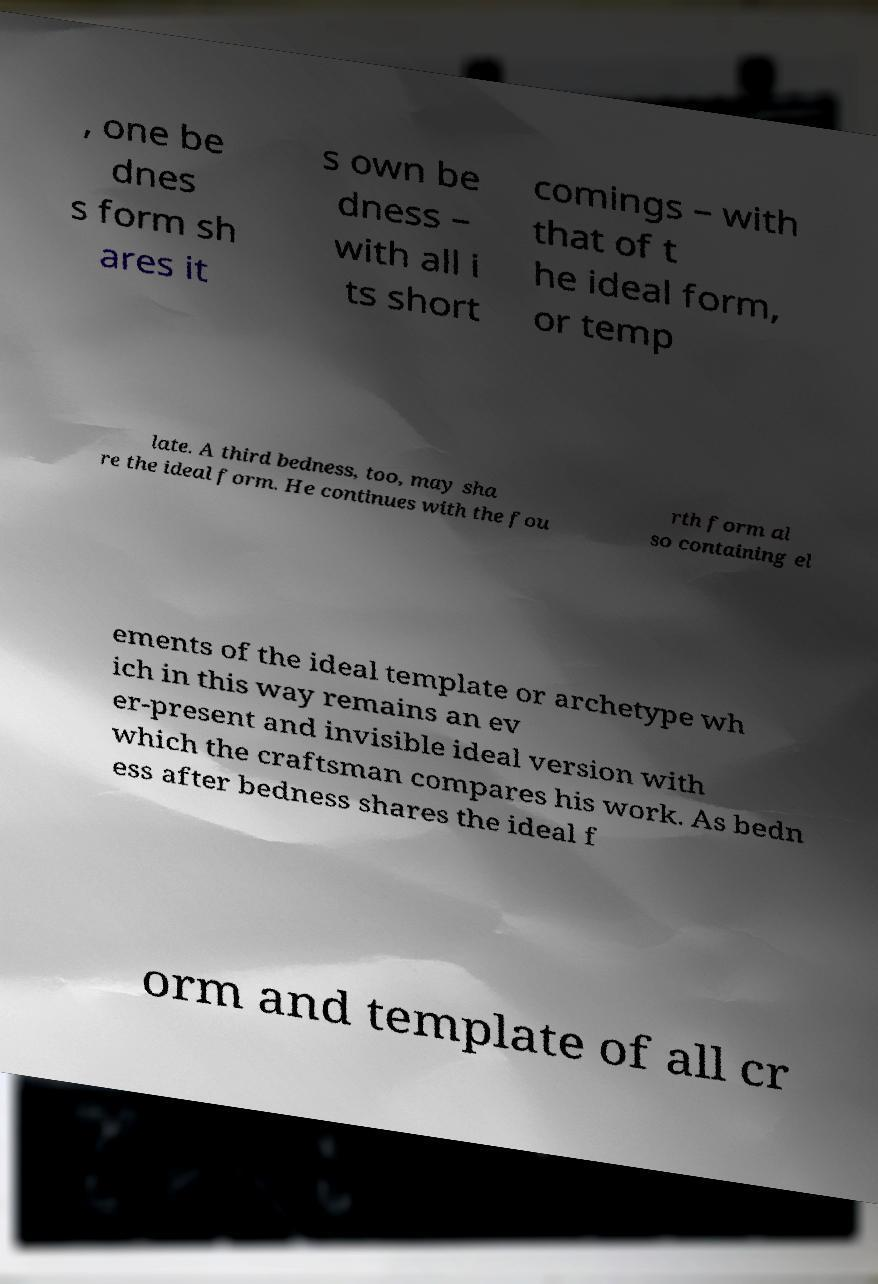Could you assist in decoding the text presented in this image and type it out clearly? , one be dnes s form sh ares it s own be dness – with all i ts short comings – with that of t he ideal form, or temp late. A third bedness, too, may sha re the ideal form. He continues with the fou rth form al so containing el ements of the ideal template or archetype wh ich in this way remains an ev er-present and invisible ideal version with which the craftsman compares his work. As bedn ess after bedness shares the ideal f orm and template of all cr 